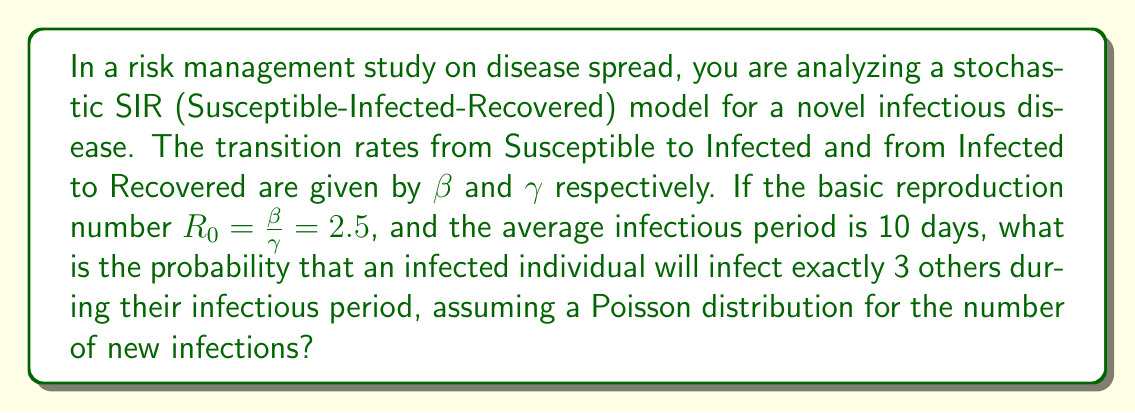Teach me how to tackle this problem. To solve this problem, we'll follow these steps:

1) First, we need to determine the rate parameters:
   - We know that $\gamma = \frac{1}{\text{average infectious period}} = \frac{1}{10}$ per day
   - Given $R_0 = \frac{\beta}{\gamma} = 2.5$, we can calculate $\beta$:
     $\beta = R_0 \cdot \gamma = 2.5 \cdot \frac{1}{10} = 0.25$ per day

2) The expected number of new infections caused by one infected individual over their entire infectious period is $R_0 = 2.5$

3) We assume the number of new infections follows a Poisson distribution. The probability mass function for a Poisson distribution is:

   $$P(X = k) = \frac{e^{-\lambda}\lambda^k}{k!}$$

   where $\lambda$ is the expected number of occurrences (in this case, $R_0 = 2.5$), and $k$ is the number of occurrences we're interested in (in this case, 3).

4) Plugging in our values:

   $$P(X = 3) = \frac{e^{-2.5}2.5^3}{3!}$$

5) Calculate:
   $$P(X = 3) = \frac{e^{-2.5} \cdot 15.625}{6} \approx 0.2138$$

Thus, the probability of an infected individual infecting exactly 3 others during their infectious period is approximately 0.2138 or 21.38%.
Answer: 0.2138 or 21.38% 